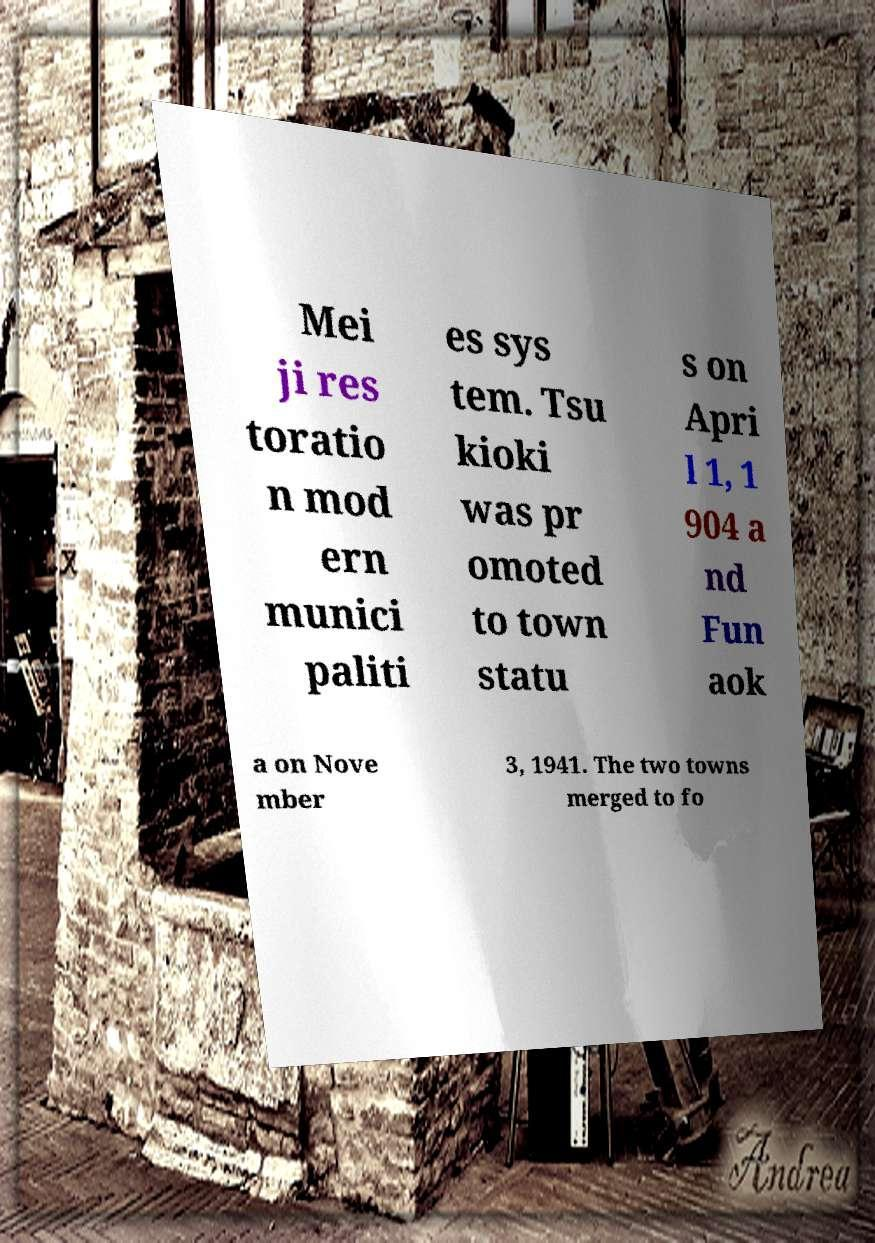For documentation purposes, I need the text within this image transcribed. Could you provide that? Mei ji res toratio n mod ern munici paliti es sys tem. Tsu kioki was pr omoted to town statu s on Apri l 1, 1 904 a nd Fun aok a on Nove mber 3, 1941. The two towns merged to fo 